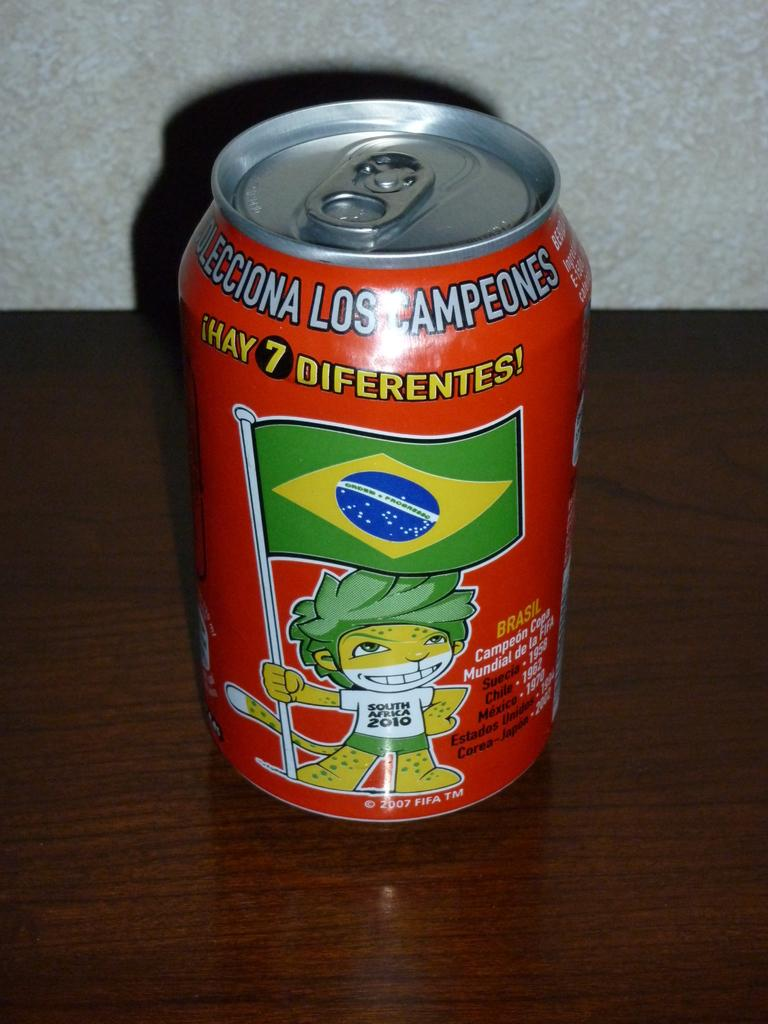<image>
Render a clear and concise summary of the photo. An orange can that says Los Campeones on it. 